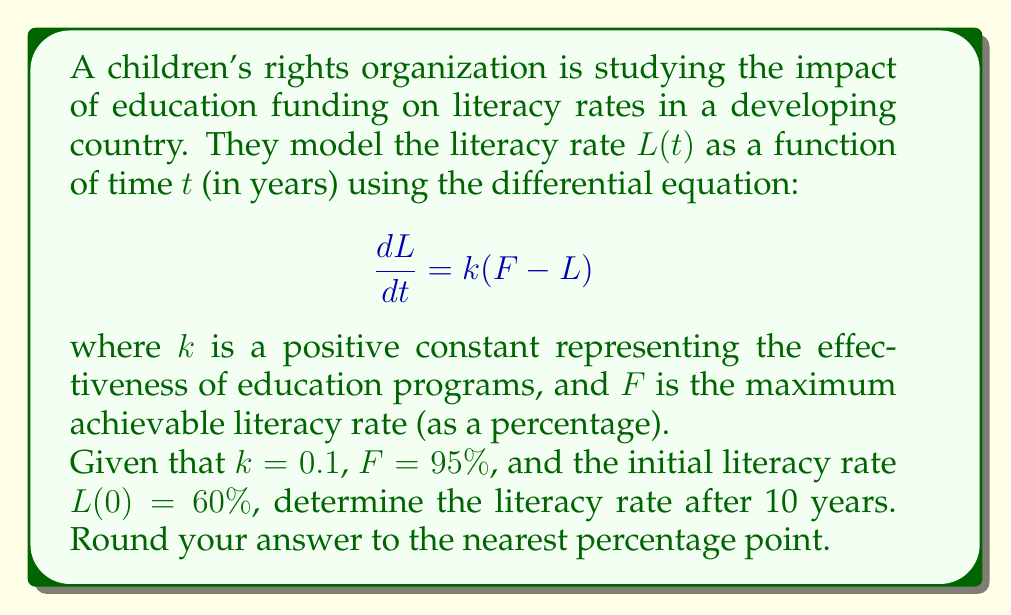What is the answer to this math problem? To solve this problem, we need to follow these steps:

1) First, we recognize this as a first-order linear differential equation.

2) The general solution to this type of equation is:

   $$L(t) = F + (L_0 - F)e^{-kt}$$

   where $L_0$ is the initial literacy rate.

3) We're given the following values:
   - $k = 0.1$
   - $F = 95\%$
   - $L_0 = L(0) = 60\%$
   - $t = 10$ years

4) Let's substitute these values into our solution:

   $$L(10) = 95 + (60 - 95)e^{-0.1(10)}$$

5) Simplify:
   $$L(10) = 95 - 35e^{-1}$$

6) Calculate $e^{-1}$:
   $$e^{-1} \approx 0.3679$$

7) Substitute this value:
   $$L(10) = 95 - 35(0.3679) = 95 - 12.8765 = 82.1235\%$$

8) Rounding to the nearest percentage point:
   $$L(10) \approx 82\%$$
Answer: 82% 